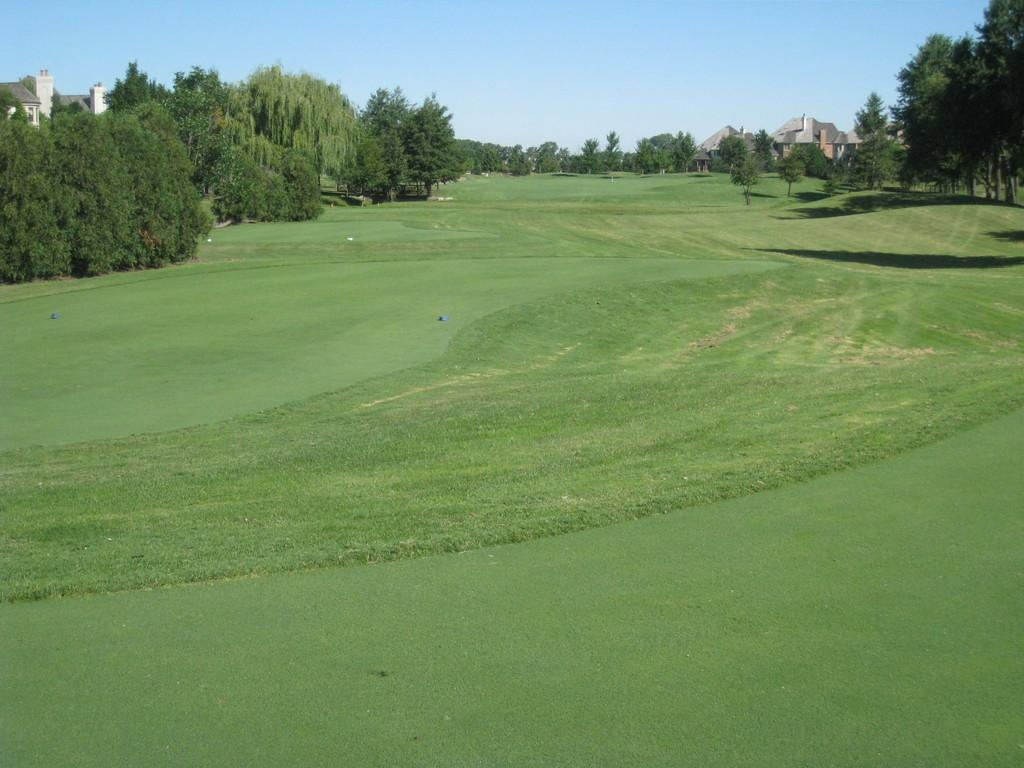What type of structures can be seen in the image? There are houses in the image. What else is present on the ground in the image? There are objects on the ground in the image. What type of vegetation is visible in the image? There are big trees in the image. What is the ground covered with in the image? There is grass on the ground in the image. What is visible at the top of the image? The sky is visible at the top of the image. What type of food is the grandmother eating in the image? There is no grandmother or food present in the image. What color is the lipstick on the person's lips in the image? There are no people or lipstick present in the image. 